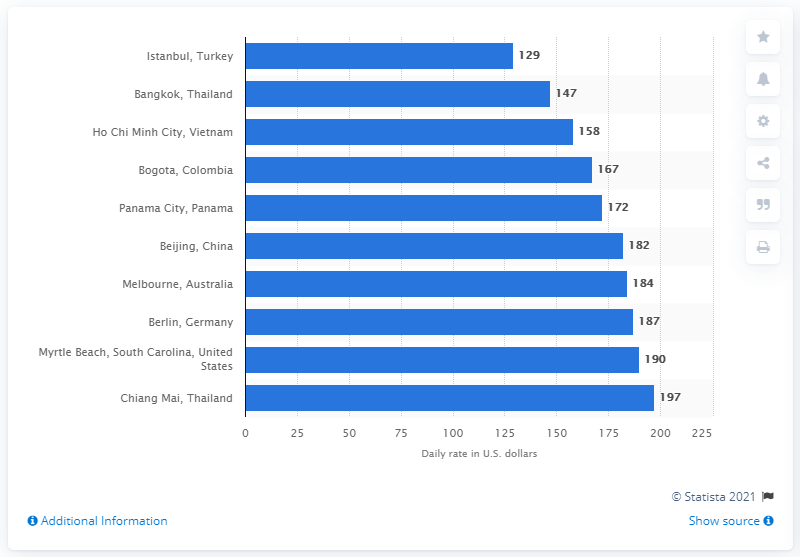Point out several critical features in this image. In 2017, the average cost of a five-star hotel in Istanbul was 129. 